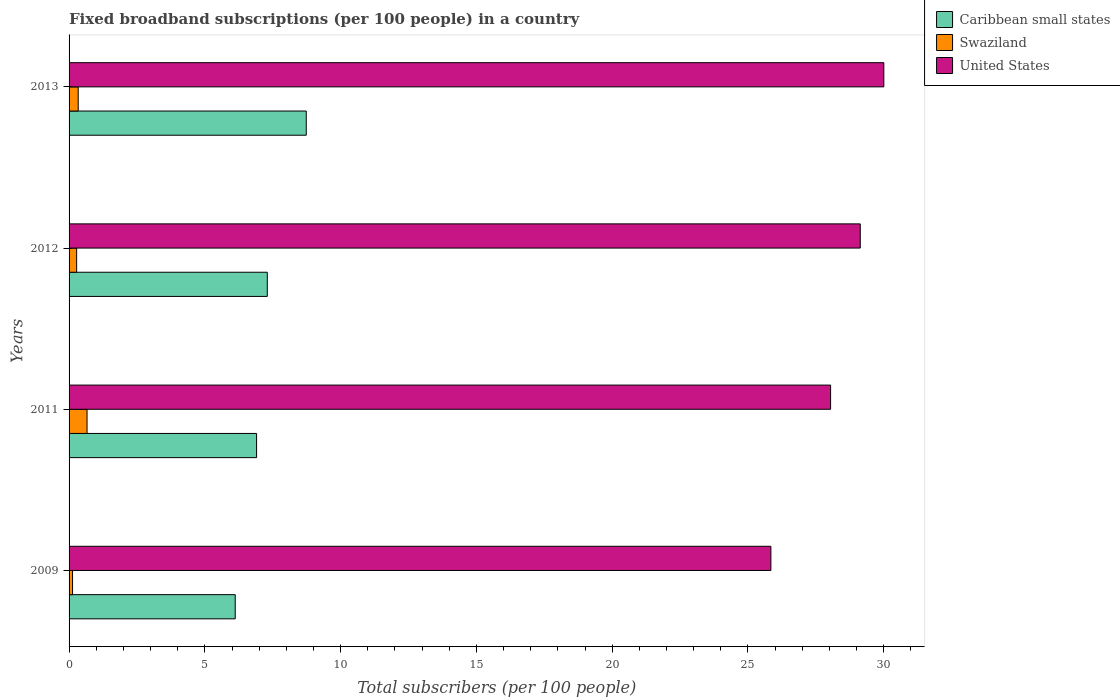How many different coloured bars are there?
Ensure brevity in your answer.  3. How many groups of bars are there?
Give a very brief answer. 4. Are the number of bars per tick equal to the number of legend labels?
Your answer should be very brief. Yes. In how many cases, is the number of bars for a given year not equal to the number of legend labels?
Your answer should be very brief. 0. What is the number of broadband subscriptions in Swaziland in 2011?
Ensure brevity in your answer.  0.66. Across all years, what is the maximum number of broadband subscriptions in United States?
Keep it short and to the point. 30. Across all years, what is the minimum number of broadband subscriptions in Caribbean small states?
Offer a very short reply. 6.12. In which year was the number of broadband subscriptions in Caribbean small states maximum?
Offer a very short reply. 2013. In which year was the number of broadband subscriptions in Caribbean small states minimum?
Make the answer very short. 2009. What is the total number of broadband subscriptions in United States in the graph?
Your answer should be compact. 113.03. What is the difference between the number of broadband subscriptions in United States in 2009 and that in 2011?
Your answer should be compact. -2.2. What is the difference between the number of broadband subscriptions in Swaziland in 2013 and the number of broadband subscriptions in United States in 2012?
Your answer should be very brief. -28.8. What is the average number of broadband subscriptions in Caribbean small states per year?
Offer a very short reply. 7.27. In the year 2013, what is the difference between the number of broadband subscriptions in Caribbean small states and number of broadband subscriptions in United States?
Offer a very short reply. -21.27. What is the ratio of the number of broadband subscriptions in United States in 2012 to that in 2013?
Offer a terse response. 0.97. Is the number of broadband subscriptions in Caribbean small states in 2012 less than that in 2013?
Your answer should be compact. Yes. What is the difference between the highest and the second highest number of broadband subscriptions in Swaziland?
Your answer should be compact. 0.33. What is the difference between the highest and the lowest number of broadband subscriptions in United States?
Ensure brevity in your answer.  4.16. Is the sum of the number of broadband subscriptions in Caribbean small states in 2012 and 2013 greater than the maximum number of broadband subscriptions in United States across all years?
Keep it short and to the point. No. What does the 2nd bar from the top in 2013 represents?
Keep it short and to the point. Swaziland. What does the 2nd bar from the bottom in 2012 represents?
Offer a terse response. Swaziland. Is it the case that in every year, the sum of the number of broadband subscriptions in Swaziland and number of broadband subscriptions in United States is greater than the number of broadband subscriptions in Caribbean small states?
Give a very brief answer. Yes. How many bars are there?
Provide a succinct answer. 12. Are the values on the major ticks of X-axis written in scientific E-notation?
Your response must be concise. No. Does the graph contain any zero values?
Your answer should be very brief. No. Where does the legend appear in the graph?
Provide a succinct answer. Top right. How many legend labels are there?
Provide a succinct answer. 3. How are the legend labels stacked?
Give a very brief answer. Vertical. What is the title of the graph?
Offer a very short reply. Fixed broadband subscriptions (per 100 people) in a country. Does "Samoa" appear as one of the legend labels in the graph?
Make the answer very short. No. What is the label or title of the X-axis?
Ensure brevity in your answer.  Total subscribers (per 100 people). What is the Total subscribers (per 100 people) in Caribbean small states in 2009?
Make the answer very short. 6.12. What is the Total subscribers (per 100 people) of Swaziland in 2009?
Your response must be concise. 0.13. What is the Total subscribers (per 100 people) of United States in 2009?
Keep it short and to the point. 25.85. What is the Total subscribers (per 100 people) of Caribbean small states in 2011?
Your response must be concise. 6.91. What is the Total subscribers (per 100 people) of Swaziland in 2011?
Keep it short and to the point. 0.66. What is the Total subscribers (per 100 people) of United States in 2011?
Ensure brevity in your answer.  28.04. What is the Total subscribers (per 100 people) in Caribbean small states in 2012?
Make the answer very short. 7.3. What is the Total subscribers (per 100 people) of Swaziland in 2012?
Keep it short and to the point. 0.28. What is the Total subscribers (per 100 people) in United States in 2012?
Keep it short and to the point. 29.14. What is the Total subscribers (per 100 people) in Caribbean small states in 2013?
Give a very brief answer. 8.74. What is the Total subscribers (per 100 people) in Swaziland in 2013?
Give a very brief answer. 0.34. What is the Total subscribers (per 100 people) in United States in 2013?
Ensure brevity in your answer.  30. Across all years, what is the maximum Total subscribers (per 100 people) of Caribbean small states?
Offer a very short reply. 8.74. Across all years, what is the maximum Total subscribers (per 100 people) of Swaziland?
Offer a very short reply. 0.66. Across all years, what is the maximum Total subscribers (per 100 people) in United States?
Keep it short and to the point. 30. Across all years, what is the minimum Total subscribers (per 100 people) of Caribbean small states?
Provide a short and direct response. 6.12. Across all years, what is the minimum Total subscribers (per 100 people) in Swaziland?
Offer a terse response. 0.13. Across all years, what is the minimum Total subscribers (per 100 people) in United States?
Provide a succinct answer. 25.85. What is the total Total subscribers (per 100 people) of Caribbean small states in the graph?
Your answer should be compact. 29.06. What is the total Total subscribers (per 100 people) of Swaziland in the graph?
Provide a short and direct response. 1.4. What is the total Total subscribers (per 100 people) of United States in the graph?
Provide a succinct answer. 113.03. What is the difference between the Total subscribers (per 100 people) in Caribbean small states in 2009 and that in 2011?
Your response must be concise. -0.79. What is the difference between the Total subscribers (per 100 people) of Swaziland in 2009 and that in 2011?
Offer a terse response. -0.53. What is the difference between the Total subscribers (per 100 people) in United States in 2009 and that in 2011?
Your answer should be very brief. -2.2. What is the difference between the Total subscribers (per 100 people) of Caribbean small states in 2009 and that in 2012?
Give a very brief answer. -1.18. What is the difference between the Total subscribers (per 100 people) of Swaziland in 2009 and that in 2012?
Provide a short and direct response. -0.15. What is the difference between the Total subscribers (per 100 people) in United States in 2009 and that in 2012?
Ensure brevity in your answer.  -3.29. What is the difference between the Total subscribers (per 100 people) in Caribbean small states in 2009 and that in 2013?
Provide a short and direct response. -2.62. What is the difference between the Total subscribers (per 100 people) in Swaziland in 2009 and that in 2013?
Offer a terse response. -0.21. What is the difference between the Total subscribers (per 100 people) of United States in 2009 and that in 2013?
Offer a terse response. -4.16. What is the difference between the Total subscribers (per 100 people) in Caribbean small states in 2011 and that in 2012?
Provide a short and direct response. -0.39. What is the difference between the Total subscribers (per 100 people) of Swaziland in 2011 and that in 2012?
Provide a succinct answer. 0.38. What is the difference between the Total subscribers (per 100 people) in United States in 2011 and that in 2012?
Keep it short and to the point. -1.09. What is the difference between the Total subscribers (per 100 people) of Caribbean small states in 2011 and that in 2013?
Give a very brief answer. -1.83. What is the difference between the Total subscribers (per 100 people) of Swaziland in 2011 and that in 2013?
Offer a very short reply. 0.33. What is the difference between the Total subscribers (per 100 people) of United States in 2011 and that in 2013?
Make the answer very short. -1.96. What is the difference between the Total subscribers (per 100 people) of Caribbean small states in 2012 and that in 2013?
Your response must be concise. -1.44. What is the difference between the Total subscribers (per 100 people) of Swaziland in 2012 and that in 2013?
Provide a succinct answer. -0.06. What is the difference between the Total subscribers (per 100 people) in United States in 2012 and that in 2013?
Keep it short and to the point. -0.87. What is the difference between the Total subscribers (per 100 people) of Caribbean small states in 2009 and the Total subscribers (per 100 people) of Swaziland in 2011?
Your response must be concise. 5.46. What is the difference between the Total subscribers (per 100 people) of Caribbean small states in 2009 and the Total subscribers (per 100 people) of United States in 2011?
Your response must be concise. -21.93. What is the difference between the Total subscribers (per 100 people) of Swaziland in 2009 and the Total subscribers (per 100 people) of United States in 2011?
Offer a terse response. -27.92. What is the difference between the Total subscribers (per 100 people) of Caribbean small states in 2009 and the Total subscribers (per 100 people) of Swaziland in 2012?
Your answer should be compact. 5.84. What is the difference between the Total subscribers (per 100 people) of Caribbean small states in 2009 and the Total subscribers (per 100 people) of United States in 2012?
Provide a succinct answer. -23.02. What is the difference between the Total subscribers (per 100 people) in Swaziland in 2009 and the Total subscribers (per 100 people) in United States in 2012?
Make the answer very short. -29.01. What is the difference between the Total subscribers (per 100 people) of Caribbean small states in 2009 and the Total subscribers (per 100 people) of Swaziland in 2013?
Make the answer very short. 5.78. What is the difference between the Total subscribers (per 100 people) in Caribbean small states in 2009 and the Total subscribers (per 100 people) in United States in 2013?
Your answer should be very brief. -23.89. What is the difference between the Total subscribers (per 100 people) of Swaziland in 2009 and the Total subscribers (per 100 people) of United States in 2013?
Your response must be concise. -29.88. What is the difference between the Total subscribers (per 100 people) in Caribbean small states in 2011 and the Total subscribers (per 100 people) in Swaziland in 2012?
Your response must be concise. 6.63. What is the difference between the Total subscribers (per 100 people) of Caribbean small states in 2011 and the Total subscribers (per 100 people) of United States in 2012?
Offer a terse response. -22.23. What is the difference between the Total subscribers (per 100 people) of Swaziland in 2011 and the Total subscribers (per 100 people) of United States in 2012?
Ensure brevity in your answer.  -28.48. What is the difference between the Total subscribers (per 100 people) of Caribbean small states in 2011 and the Total subscribers (per 100 people) of Swaziland in 2013?
Your answer should be very brief. 6.57. What is the difference between the Total subscribers (per 100 people) in Caribbean small states in 2011 and the Total subscribers (per 100 people) in United States in 2013?
Offer a terse response. -23.1. What is the difference between the Total subscribers (per 100 people) in Swaziland in 2011 and the Total subscribers (per 100 people) in United States in 2013?
Your answer should be compact. -29.34. What is the difference between the Total subscribers (per 100 people) of Caribbean small states in 2012 and the Total subscribers (per 100 people) of Swaziland in 2013?
Give a very brief answer. 6.96. What is the difference between the Total subscribers (per 100 people) in Caribbean small states in 2012 and the Total subscribers (per 100 people) in United States in 2013?
Your answer should be very brief. -22.7. What is the difference between the Total subscribers (per 100 people) in Swaziland in 2012 and the Total subscribers (per 100 people) in United States in 2013?
Keep it short and to the point. -29.73. What is the average Total subscribers (per 100 people) of Caribbean small states per year?
Ensure brevity in your answer.  7.27. What is the average Total subscribers (per 100 people) of Swaziland per year?
Offer a very short reply. 0.35. What is the average Total subscribers (per 100 people) of United States per year?
Give a very brief answer. 28.26. In the year 2009, what is the difference between the Total subscribers (per 100 people) of Caribbean small states and Total subscribers (per 100 people) of Swaziland?
Offer a terse response. 5.99. In the year 2009, what is the difference between the Total subscribers (per 100 people) in Caribbean small states and Total subscribers (per 100 people) in United States?
Offer a very short reply. -19.73. In the year 2009, what is the difference between the Total subscribers (per 100 people) in Swaziland and Total subscribers (per 100 people) in United States?
Your response must be concise. -25.72. In the year 2011, what is the difference between the Total subscribers (per 100 people) in Caribbean small states and Total subscribers (per 100 people) in Swaziland?
Make the answer very short. 6.24. In the year 2011, what is the difference between the Total subscribers (per 100 people) in Caribbean small states and Total subscribers (per 100 people) in United States?
Provide a short and direct response. -21.14. In the year 2011, what is the difference between the Total subscribers (per 100 people) in Swaziland and Total subscribers (per 100 people) in United States?
Your answer should be compact. -27.38. In the year 2012, what is the difference between the Total subscribers (per 100 people) of Caribbean small states and Total subscribers (per 100 people) of Swaziland?
Offer a terse response. 7.02. In the year 2012, what is the difference between the Total subscribers (per 100 people) in Caribbean small states and Total subscribers (per 100 people) in United States?
Offer a terse response. -21.84. In the year 2012, what is the difference between the Total subscribers (per 100 people) of Swaziland and Total subscribers (per 100 people) of United States?
Ensure brevity in your answer.  -28.86. In the year 2013, what is the difference between the Total subscribers (per 100 people) of Caribbean small states and Total subscribers (per 100 people) of Swaziland?
Offer a very short reply. 8.4. In the year 2013, what is the difference between the Total subscribers (per 100 people) in Caribbean small states and Total subscribers (per 100 people) in United States?
Give a very brief answer. -21.27. In the year 2013, what is the difference between the Total subscribers (per 100 people) of Swaziland and Total subscribers (per 100 people) of United States?
Your answer should be very brief. -29.67. What is the ratio of the Total subscribers (per 100 people) in Caribbean small states in 2009 to that in 2011?
Keep it short and to the point. 0.89. What is the ratio of the Total subscribers (per 100 people) of Swaziland in 2009 to that in 2011?
Offer a very short reply. 0.19. What is the ratio of the Total subscribers (per 100 people) of United States in 2009 to that in 2011?
Offer a very short reply. 0.92. What is the ratio of the Total subscribers (per 100 people) in Caribbean small states in 2009 to that in 2012?
Your answer should be very brief. 0.84. What is the ratio of the Total subscribers (per 100 people) in Swaziland in 2009 to that in 2012?
Give a very brief answer. 0.46. What is the ratio of the Total subscribers (per 100 people) of United States in 2009 to that in 2012?
Offer a terse response. 0.89. What is the ratio of the Total subscribers (per 100 people) of Caribbean small states in 2009 to that in 2013?
Your answer should be very brief. 0.7. What is the ratio of the Total subscribers (per 100 people) of Swaziland in 2009 to that in 2013?
Provide a short and direct response. 0.38. What is the ratio of the Total subscribers (per 100 people) of United States in 2009 to that in 2013?
Keep it short and to the point. 0.86. What is the ratio of the Total subscribers (per 100 people) in Caribbean small states in 2011 to that in 2012?
Keep it short and to the point. 0.95. What is the ratio of the Total subscribers (per 100 people) in Swaziland in 2011 to that in 2012?
Provide a short and direct response. 2.38. What is the ratio of the Total subscribers (per 100 people) of United States in 2011 to that in 2012?
Your response must be concise. 0.96. What is the ratio of the Total subscribers (per 100 people) in Caribbean small states in 2011 to that in 2013?
Keep it short and to the point. 0.79. What is the ratio of the Total subscribers (per 100 people) of Swaziland in 2011 to that in 2013?
Provide a short and direct response. 1.97. What is the ratio of the Total subscribers (per 100 people) of United States in 2011 to that in 2013?
Make the answer very short. 0.93. What is the ratio of the Total subscribers (per 100 people) in Caribbean small states in 2012 to that in 2013?
Ensure brevity in your answer.  0.84. What is the ratio of the Total subscribers (per 100 people) in Swaziland in 2012 to that in 2013?
Give a very brief answer. 0.83. What is the ratio of the Total subscribers (per 100 people) in United States in 2012 to that in 2013?
Your answer should be compact. 0.97. What is the difference between the highest and the second highest Total subscribers (per 100 people) of Caribbean small states?
Your answer should be compact. 1.44. What is the difference between the highest and the second highest Total subscribers (per 100 people) of Swaziland?
Your answer should be very brief. 0.33. What is the difference between the highest and the second highest Total subscribers (per 100 people) in United States?
Provide a short and direct response. 0.87. What is the difference between the highest and the lowest Total subscribers (per 100 people) in Caribbean small states?
Keep it short and to the point. 2.62. What is the difference between the highest and the lowest Total subscribers (per 100 people) in Swaziland?
Offer a very short reply. 0.53. What is the difference between the highest and the lowest Total subscribers (per 100 people) in United States?
Your answer should be compact. 4.16. 